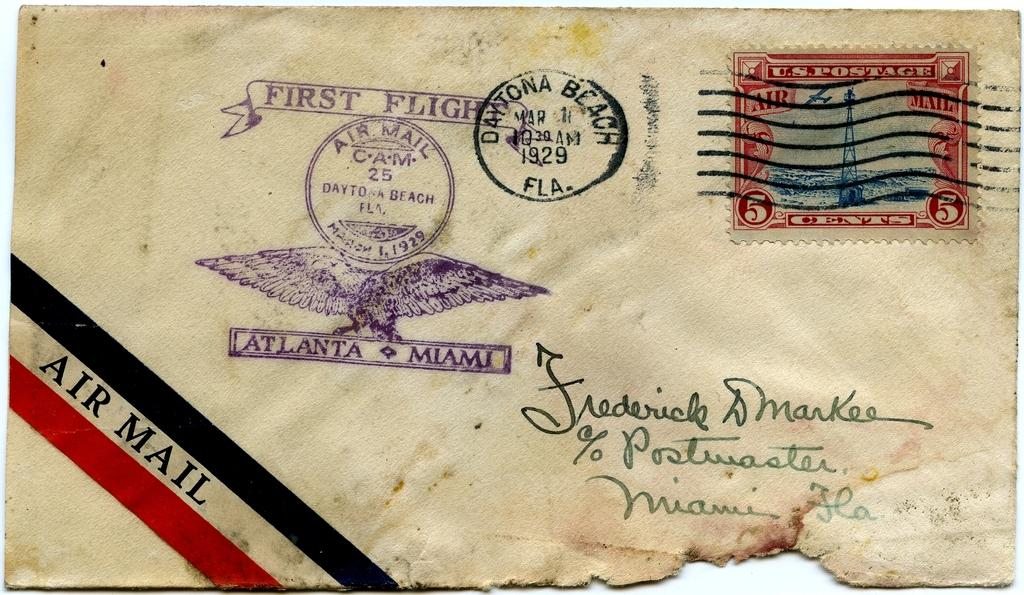<image>
Summarize the visual content of the image. An envelope from Daytona Beach with a stamp that says Atlanta-Miami underneath an eagle. 